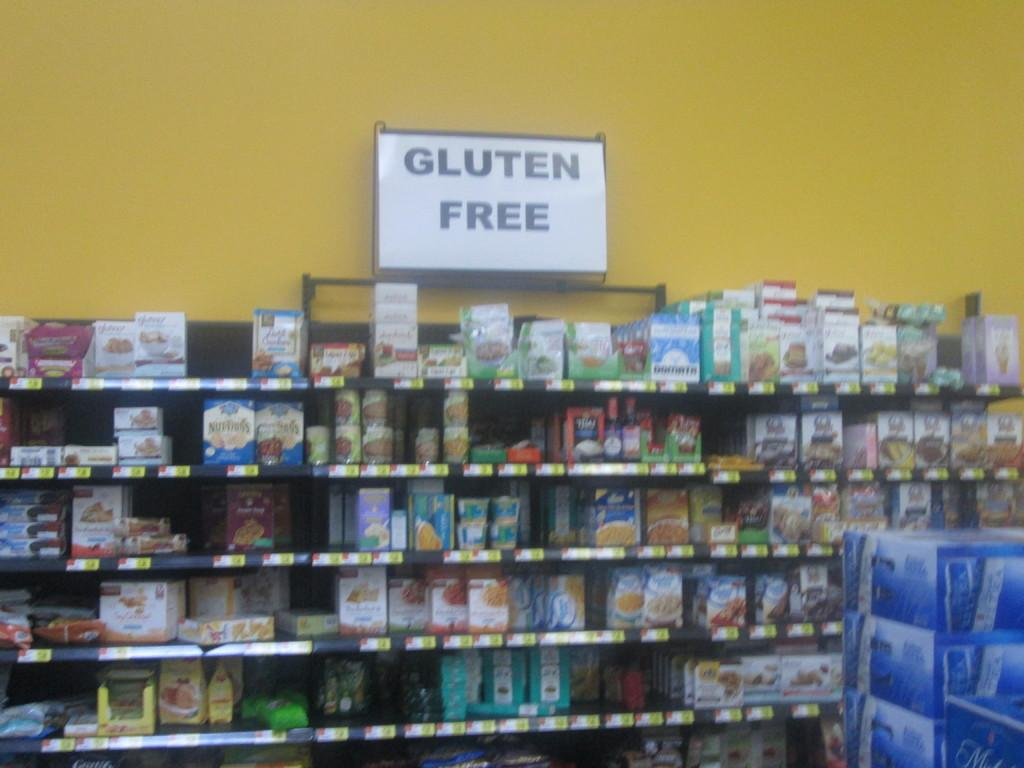<image>
Write a terse but informative summary of the picture. A shelf of products that advertise that the items are gluten free. 